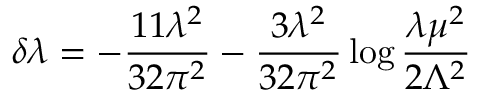Convert formula to latex. <formula><loc_0><loc_0><loc_500><loc_500>\delta \lambda = - \frac { 1 1 \lambda ^ { 2 } } { 3 2 \pi ^ { 2 } } - \frac { 3 \lambda ^ { 2 } } { 3 2 \pi ^ { 2 } } \log \frac { \lambda \mu ^ { 2 } } { 2 \Lambda ^ { 2 } }</formula> 